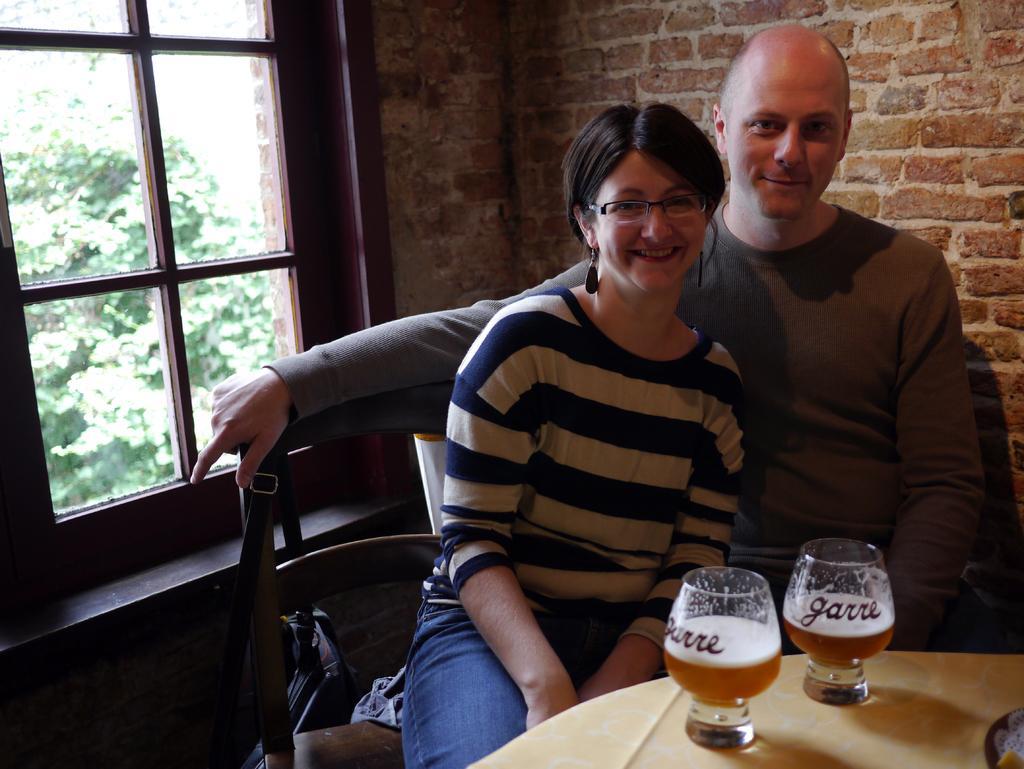In one or two sentences, can you explain what this image depicts? There are glasses on the table at the bottom side of the image, there is a man and a woman sitting in the center, there is a wall behind them and a bag at the bottom side. There is a window on the left side and trees outside the window. 